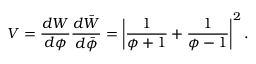<formula> <loc_0><loc_0><loc_500><loc_500>V = \frac { d W } { d \phi } \frac { d \bar { W } } { d \bar { \phi } } = \left | \frac { 1 } { \phi + 1 } + \frac { 1 } { \phi - 1 } \right | ^ { 2 } .</formula> 